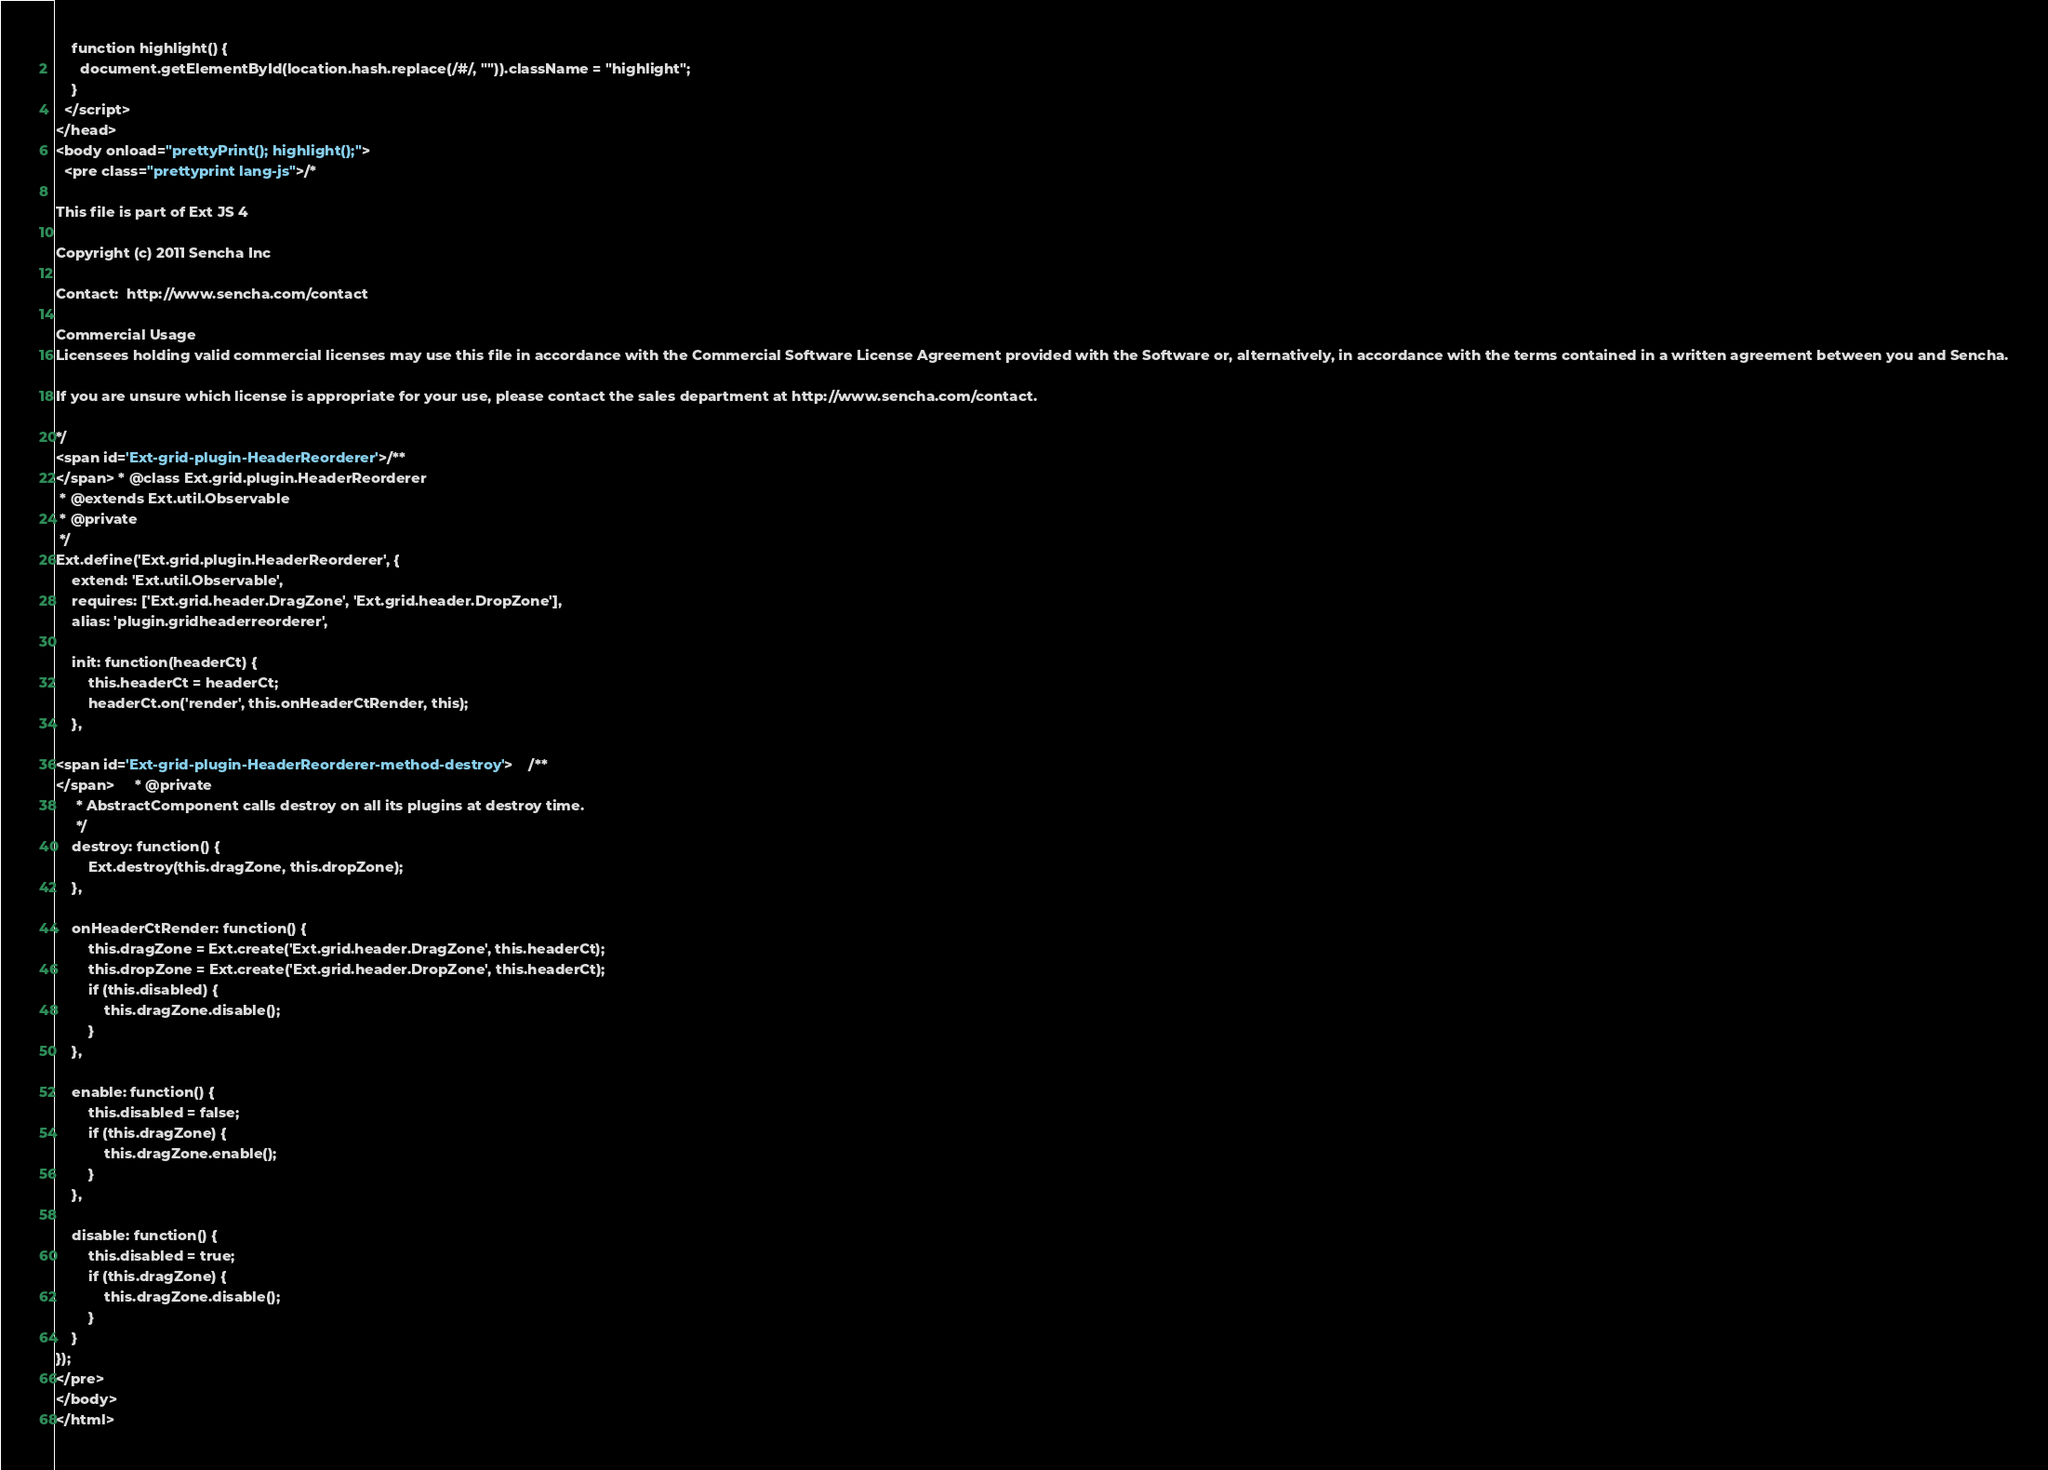<code> <loc_0><loc_0><loc_500><loc_500><_HTML_>    function highlight() {
      document.getElementById(location.hash.replace(/#/, "")).className = "highlight";
    }
  </script>
</head>
<body onload="prettyPrint(); highlight();">
  <pre class="prettyprint lang-js">/*

This file is part of Ext JS 4

Copyright (c) 2011 Sencha Inc

Contact:  http://www.sencha.com/contact

Commercial Usage
Licensees holding valid commercial licenses may use this file in accordance with the Commercial Software License Agreement provided with the Software or, alternatively, in accordance with the terms contained in a written agreement between you and Sencha.

If you are unsure which license is appropriate for your use, please contact the sales department at http://www.sencha.com/contact.

*/
<span id='Ext-grid-plugin-HeaderReorderer'>/**
</span> * @class Ext.grid.plugin.HeaderReorderer
 * @extends Ext.util.Observable
 * @private
 */
Ext.define('Ext.grid.plugin.HeaderReorderer', {
    extend: 'Ext.util.Observable',
    requires: ['Ext.grid.header.DragZone', 'Ext.grid.header.DropZone'],
    alias: 'plugin.gridheaderreorderer',

    init: function(headerCt) {
        this.headerCt = headerCt;
        headerCt.on('render', this.onHeaderCtRender, this);
    },

<span id='Ext-grid-plugin-HeaderReorderer-method-destroy'>    /**
</span>     * @private
     * AbstractComponent calls destroy on all its plugins at destroy time.
     */
    destroy: function() {
        Ext.destroy(this.dragZone, this.dropZone);
    },

    onHeaderCtRender: function() {
        this.dragZone = Ext.create('Ext.grid.header.DragZone', this.headerCt);
        this.dropZone = Ext.create('Ext.grid.header.DropZone', this.headerCt);
        if (this.disabled) {
            this.dragZone.disable();
        }
    },
    
    enable: function() {
        this.disabled = false;
        if (this.dragZone) {
            this.dragZone.enable();
        }
    },
    
    disable: function() {
        this.disabled = true;
        if (this.dragZone) {
            this.dragZone.disable();
        }
    }
});
</pre>
</body>
</html>
</code> 